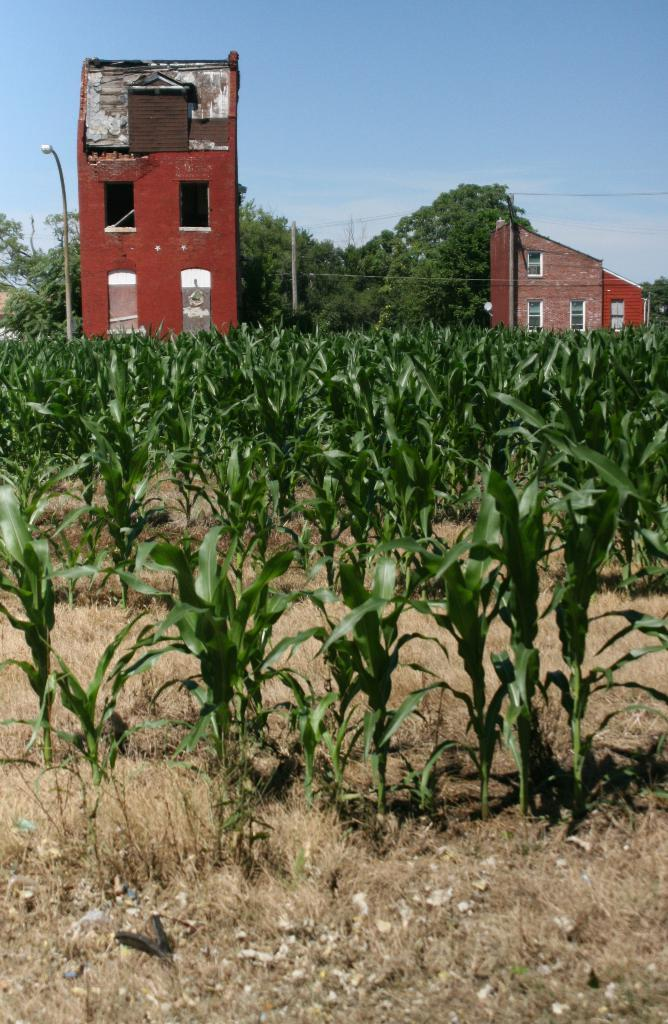What type of structures can be seen in the image? There are buildings in the image. What other natural elements are present in the image? There are trees and dry grass visible in the image. Can you describe any man-made objects in the image? There is a light pole in the image. What feature can be seen on the buildings and possibly other structures? There are windows in the image. What type of vegetation is present in the image? Green plants are present in the image. What is the color of the sky in the image? The sky is blue in color. Absurd Question/Answer: How many chairs are visible in the image? There are no chairs present in the image. What type of whip is being used to control the trees in the image? There is no whip or any indication of controlling the trees in the image. 